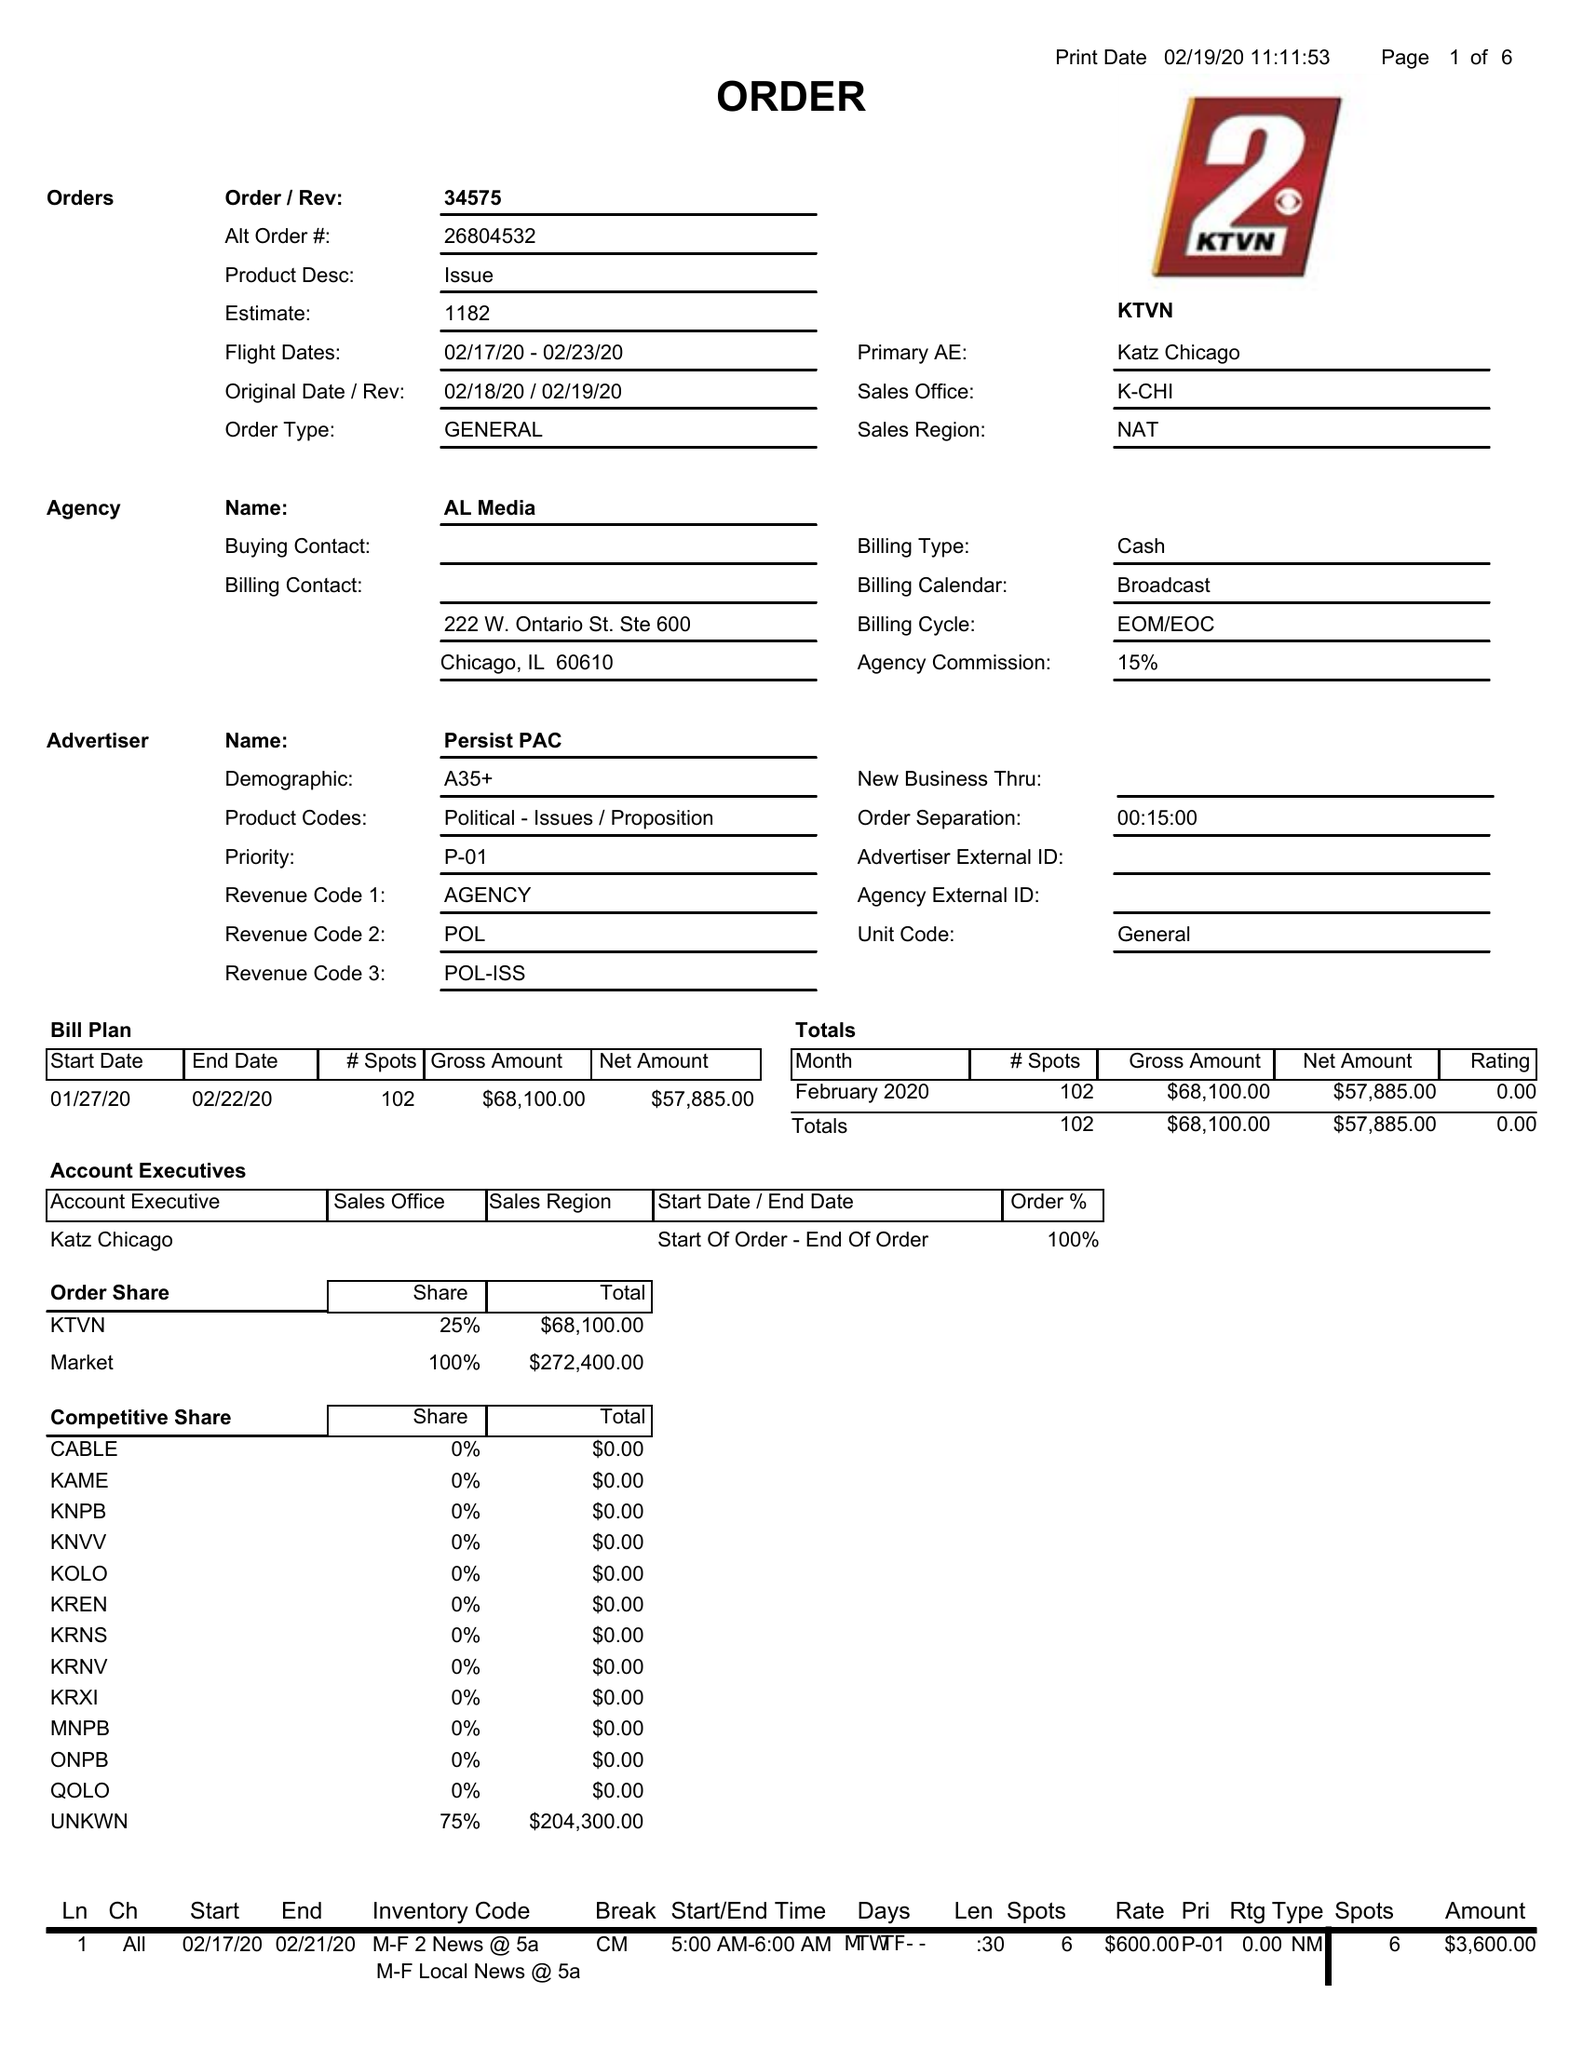What is the value for the advertiser?
Answer the question using a single word or phrase. PERSIST PAC 